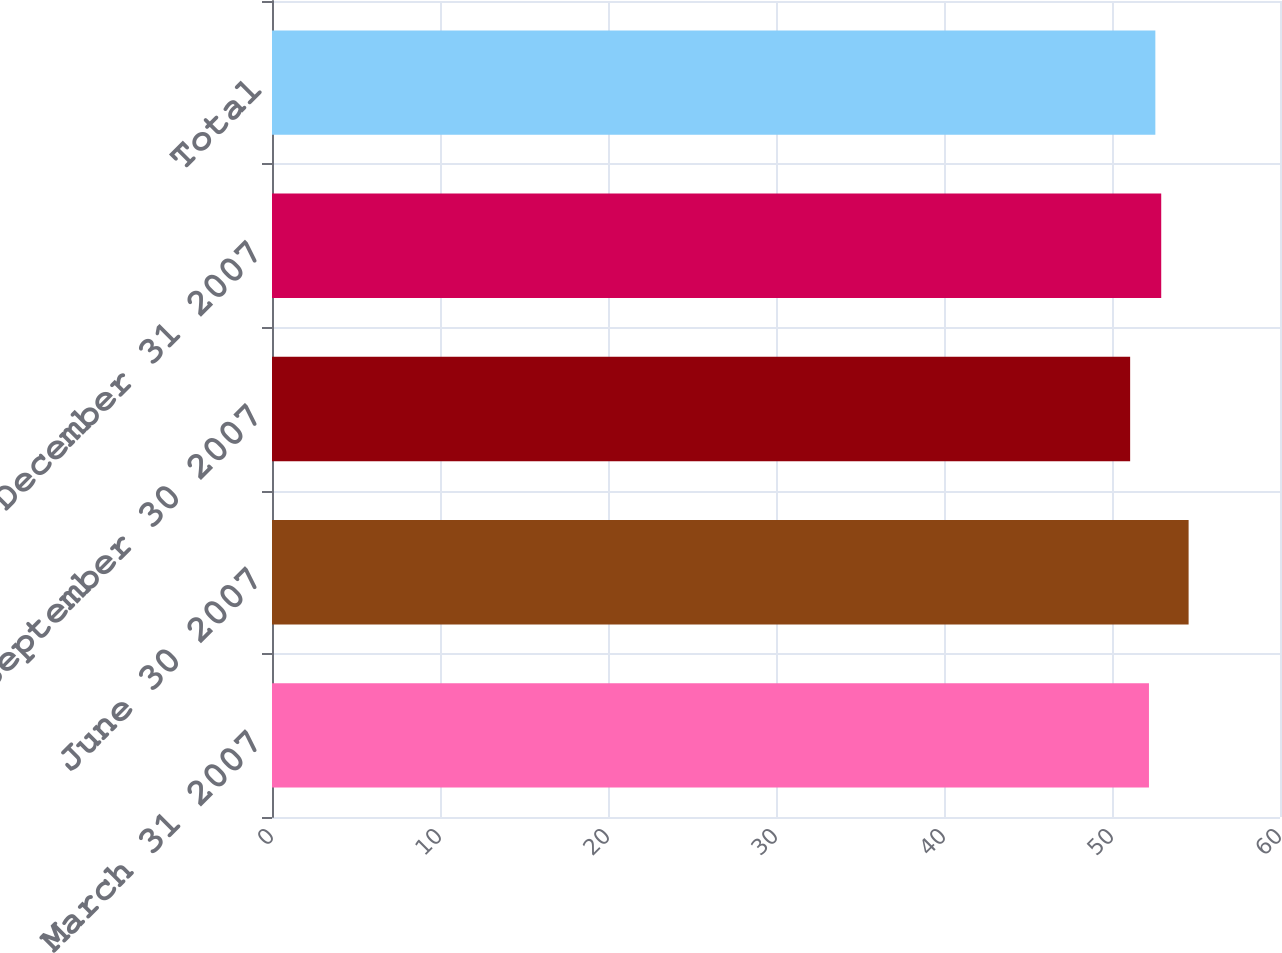Convert chart to OTSL. <chart><loc_0><loc_0><loc_500><loc_500><bar_chart><fcel>March 31 2007<fcel>June 30 2007<fcel>September 30 2007<fcel>December 31 2007<fcel>Total<nl><fcel>52.2<fcel>54.56<fcel>51.08<fcel>52.93<fcel>52.58<nl></chart> 